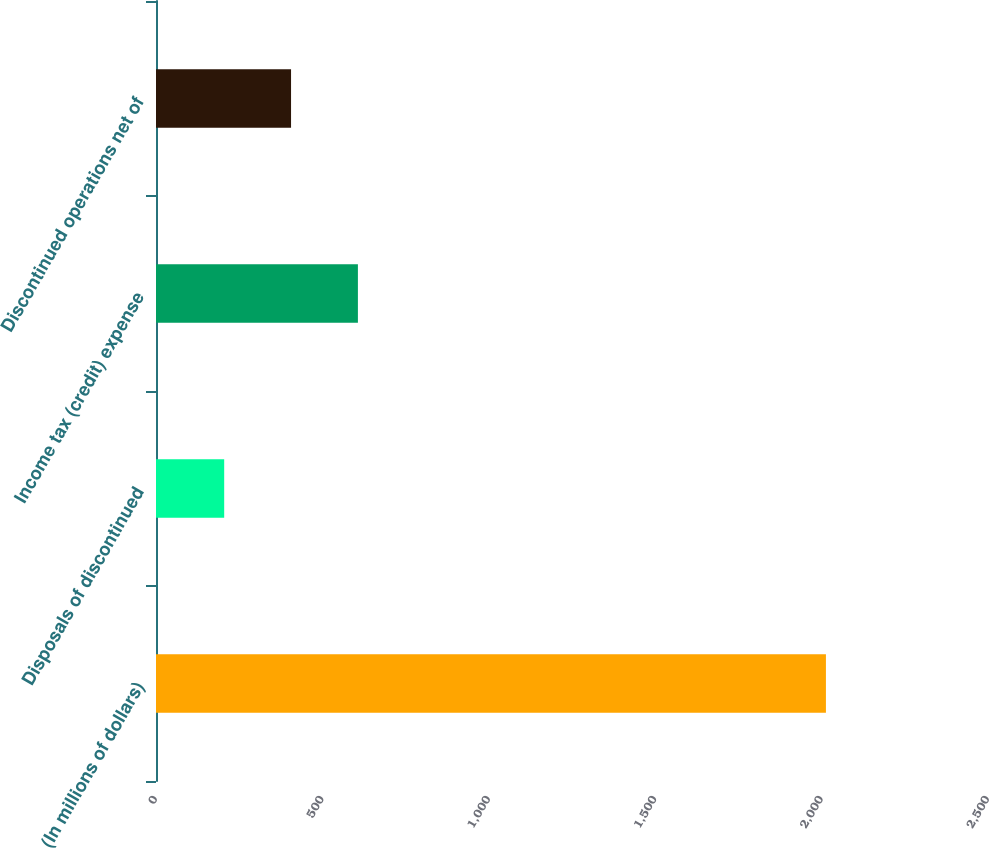Convert chart to OTSL. <chart><loc_0><loc_0><loc_500><loc_500><bar_chart><fcel>(In millions of dollars)<fcel>Disposals of discontinued<fcel>Income tax (credit) expense<fcel>Discontinued operations net of<nl><fcel>2013<fcel>204.9<fcel>606.7<fcel>405.8<nl></chart> 